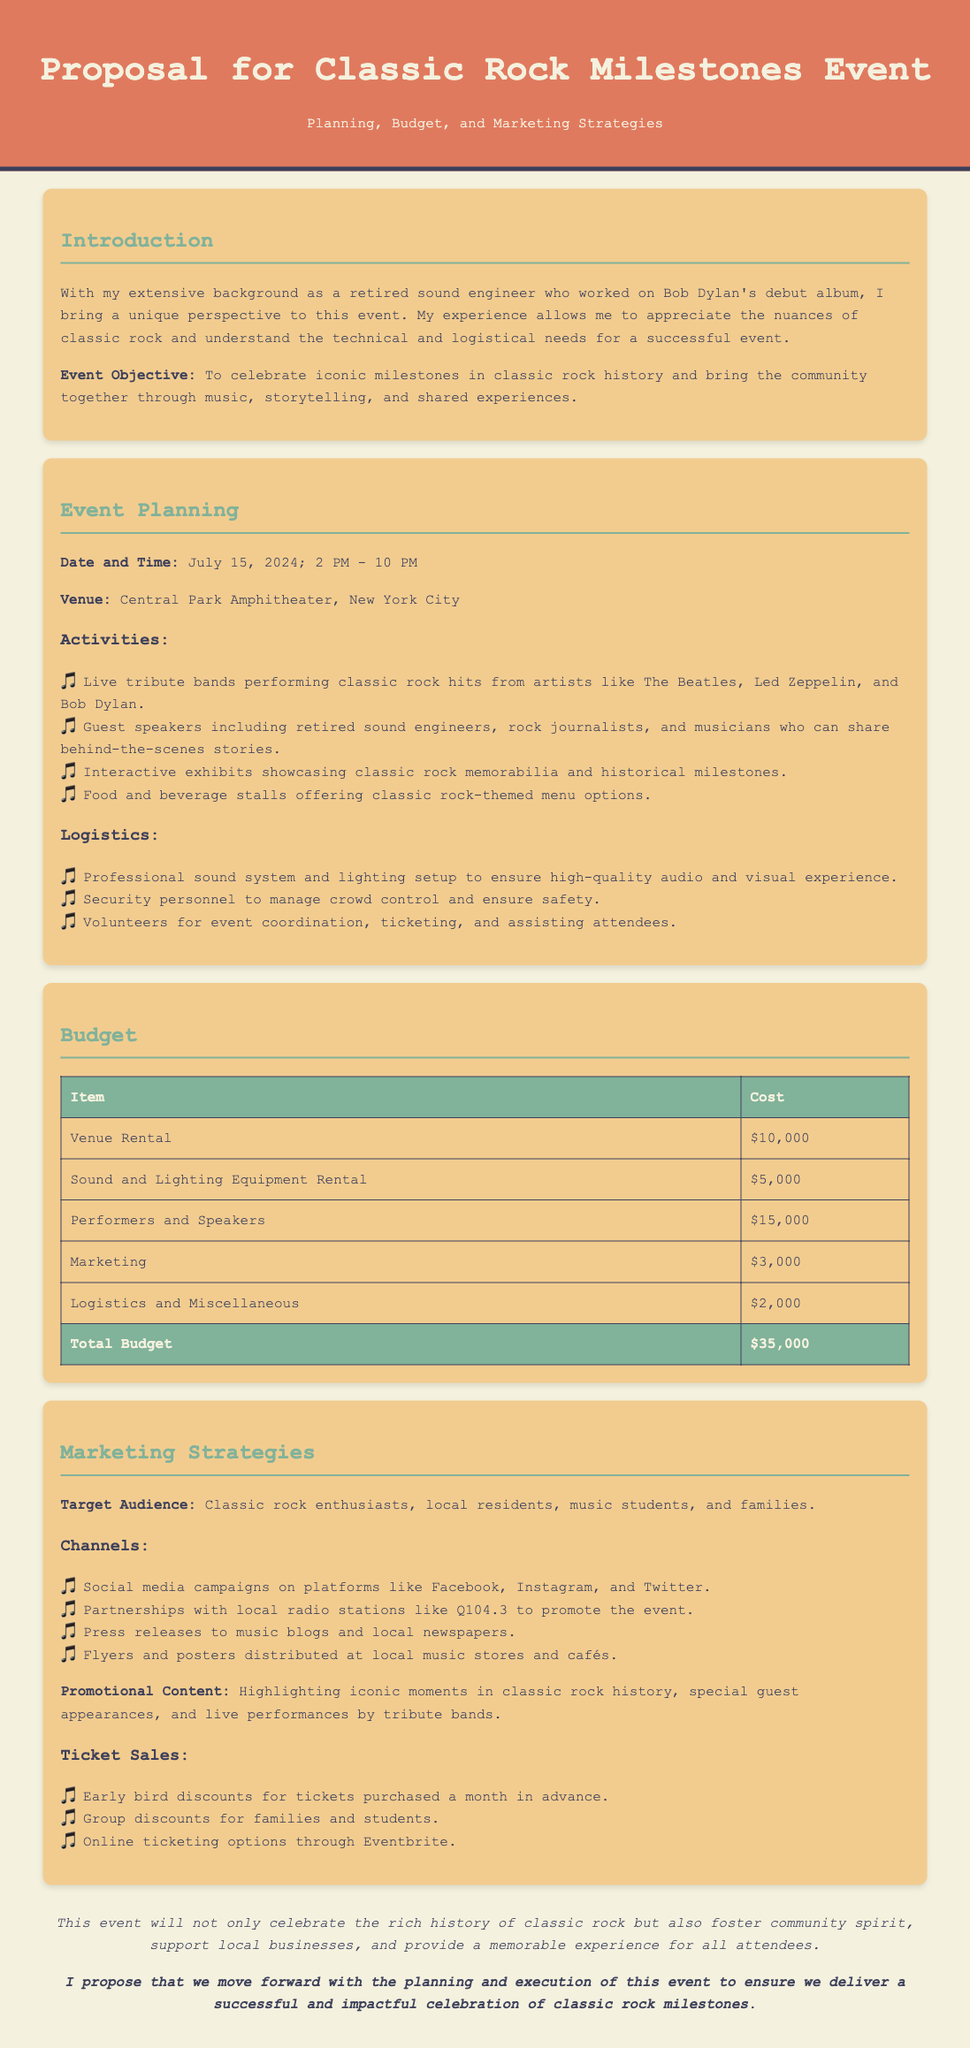what is the event date? The event date is specified clearly in the document as July 15, 2024.
Answer: July 15, 2024 what is the venue for the event? The venue mentioned in the document is the Central Park Amphitheater, New York City.
Answer: Central Park Amphitheater, New York City how much is the total budget for the event? The total budget can be found in the budget table, totaling $35,000.
Answer: $35,000 who are the guest speakers at the event? The document lists guest speakers including retired sound engineers, rock journalists, and musicians.
Answer: Retired sound engineers, rock journalists, and musicians what marketing channels are mentioned? The document outlines channels such as social media campaigns, partnerships with local radio stations, and press releases.
Answer: Social media campaigns, partnerships with local radio stations, and press releases what type of discounts are offered for ticket sales? The document mentions early bird and group discounts for ticket sales.
Answer: Early bird and group discounts how many activities are listed in the event planning section? The event planning section lists four activities in total.
Answer: Four activities what is the main objective of the event? The document states that the objective is to celebrate iconic milestones in classic rock history.
Answer: To celebrate iconic milestones in classic rock history what is the cost of sound and lighting equipment rental? The budget table specifies the cost for sound and lighting equipment rental as $5,000.
Answer: $5,000 